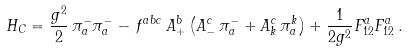<formula> <loc_0><loc_0><loc_500><loc_500>H _ { C } = \frac { g ^ { 2 } } { 2 } \, \pi ^ { - } _ { a } \pi ^ { - } _ { a } - \, f ^ { a b c } \, A ^ { b } _ { + } \left ( A ^ { c } _ { - } \, \pi ^ { - } _ { a } + A ^ { c } _ { k } \, \pi ^ { k } _ { a } \right ) + \frac { 1 } { 2 g ^ { 2 } } F ^ { a } _ { 1 2 } F ^ { a } _ { 1 2 } \, .</formula> 